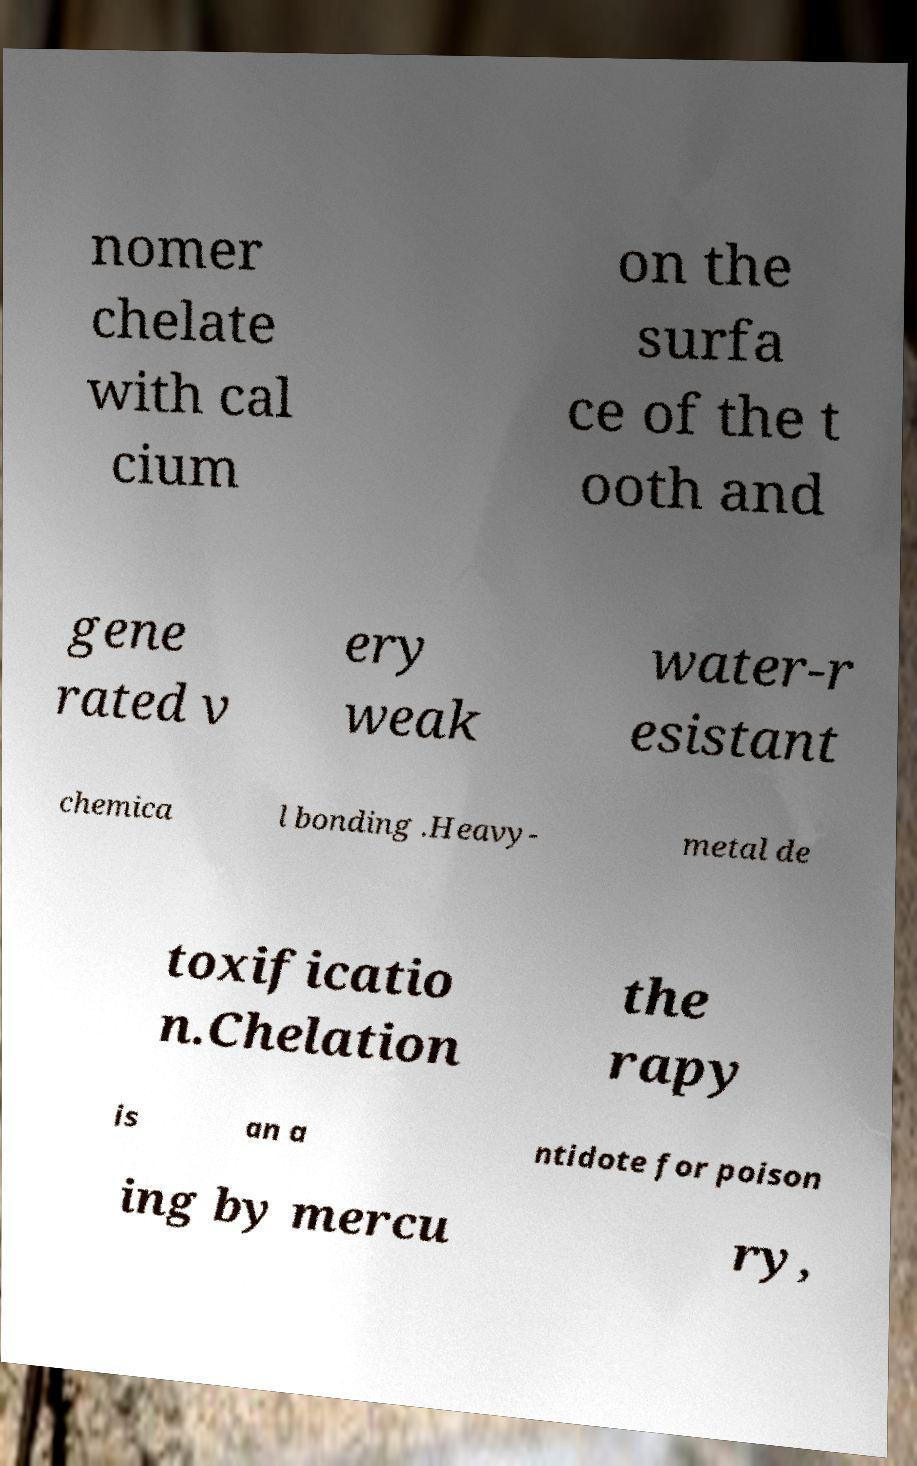There's text embedded in this image that I need extracted. Can you transcribe it verbatim? nomer chelate with cal cium on the surfa ce of the t ooth and gene rated v ery weak water-r esistant chemica l bonding .Heavy- metal de toxificatio n.Chelation the rapy is an a ntidote for poison ing by mercu ry, 